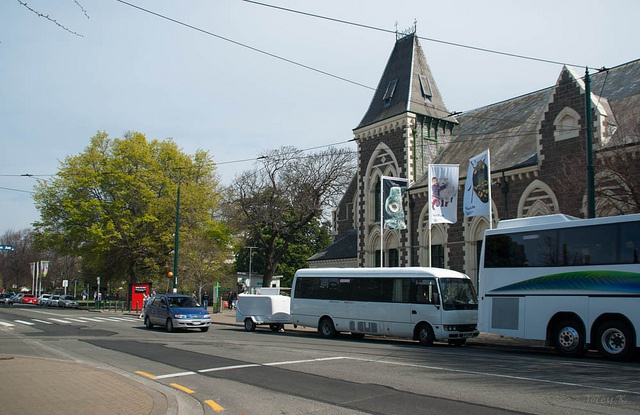Describe the objects in this image and their specific colors. I can see bus in lightblue, black, gray, and blue tones, bus in lightblue, black, gray, and purple tones, car in lightblue, black, gray, blue, and navy tones, car in lightblue, black, gray, and purple tones, and car in lightblue, black, brown, and maroon tones in this image. 